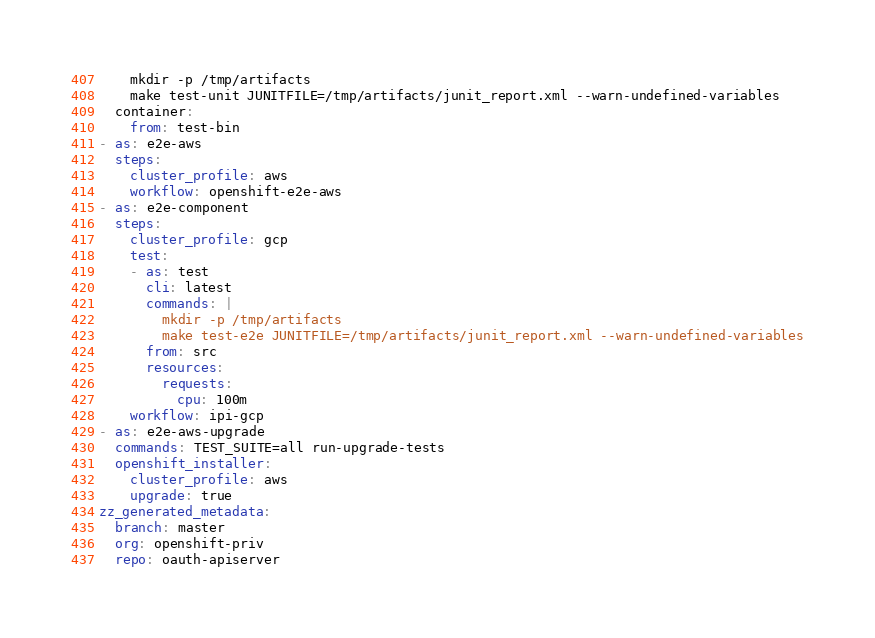Convert code to text. <code><loc_0><loc_0><loc_500><loc_500><_YAML_>    mkdir -p /tmp/artifacts
    make test-unit JUNITFILE=/tmp/artifacts/junit_report.xml --warn-undefined-variables
  container:
    from: test-bin
- as: e2e-aws
  steps:
    cluster_profile: aws
    workflow: openshift-e2e-aws
- as: e2e-component
  steps:
    cluster_profile: gcp
    test:
    - as: test
      cli: latest
      commands: |
        mkdir -p /tmp/artifacts
        make test-e2e JUNITFILE=/tmp/artifacts/junit_report.xml --warn-undefined-variables
      from: src
      resources:
        requests:
          cpu: 100m
    workflow: ipi-gcp
- as: e2e-aws-upgrade
  commands: TEST_SUITE=all run-upgrade-tests
  openshift_installer:
    cluster_profile: aws
    upgrade: true
zz_generated_metadata:
  branch: master
  org: openshift-priv
  repo: oauth-apiserver
</code> 